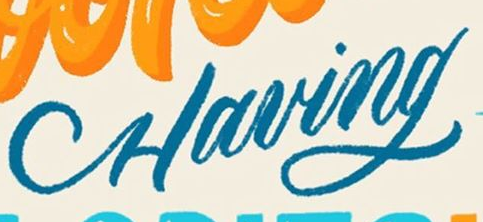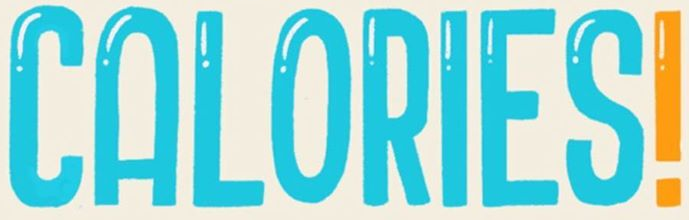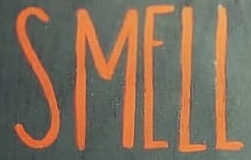What words are shown in these images in order, separated by a semicolon? Having; CALORIES!; SMELL 